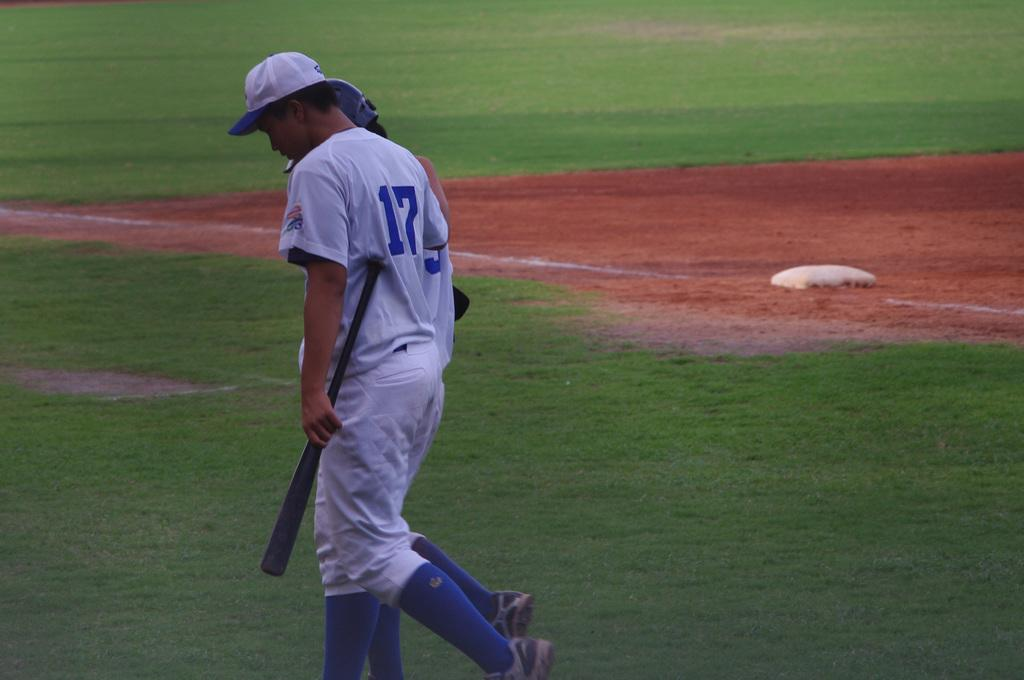<image>
Create a compact narrative representing the image presented. A baseball player wearing jersey number 17 and carrying a bat walks around a field with another player. 